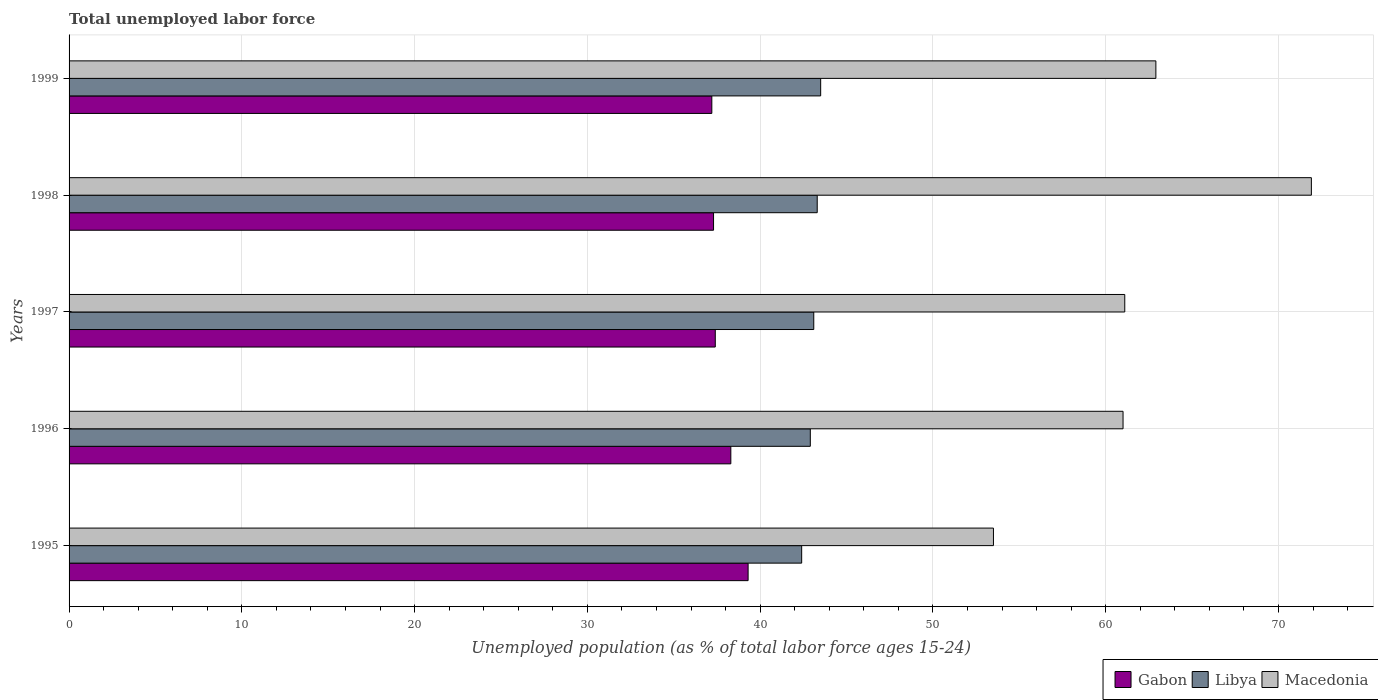How many bars are there on the 4th tick from the top?
Your answer should be compact. 3. How many bars are there on the 1st tick from the bottom?
Ensure brevity in your answer.  3. What is the label of the 3rd group of bars from the top?
Your answer should be very brief. 1997. In how many cases, is the number of bars for a given year not equal to the number of legend labels?
Your answer should be compact. 0. What is the percentage of unemployed population in in Gabon in 1999?
Make the answer very short. 37.2. Across all years, what is the maximum percentage of unemployed population in in Gabon?
Your answer should be very brief. 39.3. Across all years, what is the minimum percentage of unemployed population in in Libya?
Offer a terse response. 42.4. What is the total percentage of unemployed population in in Macedonia in the graph?
Make the answer very short. 310.4. What is the difference between the percentage of unemployed population in in Gabon in 1995 and that in 1997?
Provide a short and direct response. 1.9. What is the difference between the percentage of unemployed population in in Libya in 1997 and the percentage of unemployed population in in Gabon in 1998?
Give a very brief answer. 5.8. What is the average percentage of unemployed population in in Libya per year?
Provide a succinct answer. 43.04. In the year 1997, what is the difference between the percentage of unemployed population in in Gabon and percentage of unemployed population in in Libya?
Make the answer very short. -5.7. In how many years, is the percentage of unemployed population in in Libya greater than 68 %?
Ensure brevity in your answer.  0. What is the ratio of the percentage of unemployed population in in Gabon in 1995 to that in 1996?
Ensure brevity in your answer.  1.03. Is the percentage of unemployed population in in Gabon in 1995 less than that in 1996?
Ensure brevity in your answer.  No. What is the difference between the highest and the second highest percentage of unemployed population in in Libya?
Make the answer very short. 0.2. What is the difference between the highest and the lowest percentage of unemployed population in in Libya?
Your answer should be compact. 1.1. In how many years, is the percentage of unemployed population in in Gabon greater than the average percentage of unemployed population in in Gabon taken over all years?
Give a very brief answer. 2. Is the sum of the percentage of unemployed population in in Libya in 1998 and 1999 greater than the maximum percentage of unemployed population in in Gabon across all years?
Your answer should be very brief. Yes. What does the 1st bar from the top in 1998 represents?
Provide a succinct answer. Macedonia. What does the 2nd bar from the bottom in 1998 represents?
Keep it short and to the point. Libya. How many bars are there?
Make the answer very short. 15. How many years are there in the graph?
Provide a short and direct response. 5. What is the difference between two consecutive major ticks on the X-axis?
Offer a very short reply. 10. Are the values on the major ticks of X-axis written in scientific E-notation?
Keep it short and to the point. No. Does the graph contain any zero values?
Provide a succinct answer. No. Does the graph contain grids?
Provide a short and direct response. Yes. Where does the legend appear in the graph?
Provide a short and direct response. Bottom right. How many legend labels are there?
Your answer should be compact. 3. What is the title of the graph?
Keep it short and to the point. Total unemployed labor force. Does "South Africa" appear as one of the legend labels in the graph?
Your response must be concise. No. What is the label or title of the X-axis?
Provide a short and direct response. Unemployed population (as % of total labor force ages 15-24). What is the label or title of the Y-axis?
Your response must be concise. Years. What is the Unemployed population (as % of total labor force ages 15-24) of Gabon in 1995?
Provide a succinct answer. 39.3. What is the Unemployed population (as % of total labor force ages 15-24) in Libya in 1995?
Your answer should be very brief. 42.4. What is the Unemployed population (as % of total labor force ages 15-24) of Macedonia in 1995?
Keep it short and to the point. 53.5. What is the Unemployed population (as % of total labor force ages 15-24) of Gabon in 1996?
Ensure brevity in your answer.  38.3. What is the Unemployed population (as % of total labor force ages 15-24) in Libya in 1996?
Ensure brevity in your answer.  42.9. What is the Unemployed population (as % of total labor force ages 15-24) of Macedonia in 1996?
Keep it short and to the point. 61. What is the Unemployed population (as % of total labor force ages 15-24) of Gabon in 1997?
Your response must be concise. 37.4. What is the Unemployed population (as % of total labor force ages 15-24) of Libya in 1997?
Offer a terse response. 43.1. What is the Unemployed population (as % of total labor force ages 15-24) of Macedonia in 1997?
Your response must be concise. 61.1. What is the Unemployed population (as % of total labor force ages 15-24) in Gabon in 1998?
Offer a terse response. 37.3. What is the Unemployed population (as % of total labor force ages 15-24) in Libya in 1998?
Keep it short and to the point. 43.3. What is the Unemployed population (as % of total labor force ages 15-24) of Macedonia in 1998?
Provide a succinct answer. 71.9. What is the Unemployed population (as % of total labor force ages 15-24) of Gabon in 1999?
Make the answer very short. 37.2. What is the Unemployed population (as % of total labor force ages 15-24) of Libya in 1999?
Ensure brevity in your answer.  43.5. What is the Unemployed population (as % of total labor force ages 15-24) of Macedonia in 1999?
Offer a very short reply. 62.9. Across all years, what is the maximum Unemployed population (as % of total labor force ages 15-24) of Gabon?
Give a very brief answer. 39.3. Across all years, what is the maximum Unemployed population (as % of total labor force ages 15-24) in Libya?
Provide a short and direct response. 43.5. Across all years, what is the maximum Unemployed population (as % of total labor force ages 15-24) of Macedonia?
Ensure brevity in your answer.  71.9. Across all years, what is the minimum Unemployed population (as % of total labor force ages 15-24) of Gabon?
Your answer should be compact. 37.2. Across all years, what is the minimum Unemployed population (as % of total labor force ages 15-24) in Libya?
Your response must be concise. 42.4. Across all years, what is the minimum Unemployed population (as % of total labor force ages 15-24) of Macedonia?
Your answer should be very brief. 53.5. What is the total Unemployed population (as % of total labor force ages 15-24) in Gabon in the graph?
Offer a very short reply. 189.5. What is the total Unemployed population (as % of total labor force ages 15-24) of Libya in the graph?
Provide a short and direct response. 215.2. What is the total Unemployed population (as % of total labor force ages 15-24) of Macedonia in the graph?
Provide a succinct answer. 310.4. What is the difference between the Unemployed population (as % of total labor force ages 15-24) in Libya in 1995 and that in 1996?
Your answer should be very brief. -0.5. What is the difference between the Unemployed population (as % of total labor force ages 15-24) in Macedonia in 1995 and that in 1996?
Offer a very short reply. -7.5. What is the difference between the Unemployed population (as % of total labor force ages 15-24) in Gabon in 1995 and that in 1997?
Your response must be concise. 1.9. What is the difference between the Unemployed population (as % of total labor force ages 15-24) of Libya in 1995 and that in 1997?
Offer a very short reply. -0.7. What is the difference between the Unemployed population (as % of total labor force ages 15-24) of Libya in 1995 and that in 1998?
Offer a very short reply. -0.9. What is the difference between the Unemployed population (as % of total labor force ages 15-24) of Macedonia in 1995 and that in 1998?
Provide a short and direct response. -18.4. What is the difference between the Unemployed population (as % of total labor force ages 15-24) in Macedonia in 1995 and that in 1999?
Offer a terse response. -9.4. What is the difference between the Unemployed population (as % of total labor force ages 15-24) in Gabon in 1996 and that in 1997?
Your answer should be compact. 0.9. What is the difference between the Unemployed population (as % of total labor force ages 15-24) of Libya in 1996 and that in 1997?
Give a very brief answer. -0.2. What is the difference between the Unemployed population (as % of total labor force ages 15-24) in Gabon in 1996 and that in 1998?
Give a very brief answer. 1. What is the difference between the Unemployed population (as % of total labor force ages 15-24) of Libya in 1996 and that in 1998?
Give a very brief answer. -0.4. What is the difference between the Unemployed population (as % of total labor force ages 15-24) in Macedonia in 1997 and that in 1999?
Ensure brevity in your answer.  -1.8. What is the difference between the Unemployed population (as % of total labor force ages 15-24) in Gabon in 1998 and that in 1999?
Your answer should be compact. 0.1. What is the difference between the Unemployed population (as % of total labor force ages 15-24) in Libya in 1998 and that in 1999?
Your answer should be very brief. -0.2. What is the difference between the Unemployed population (as % of total labor force ages 15-24) of Gabon in 1995 and the Unemployed population (as % of total labor force ages 15-24) of Macedonia in 1996?
Make the answer very short. -21.7. What is the difference between the Unemployed population (as % of total labor force ages 15-24) in Libya in 1995 and the Unemployed population (as % of total labor force ages 15-24) in Macedonia in 1996?
Ensure brevity in your answer.  -18.6. What is the difference between the Unemployed population (as % of total labor force ages 15-24) in Gabon in 1995 and the Unemployed population (as % of total labor force ages 15-24) in Macedonia in 1997?
Your response must be concise. -21.8. What is the difference between the Unemployed population (as % of total labor force ages 15-24) of Libya in 1995 and the Unemployed population (as % of total labor force ages 15-24) of Macedonia in 1997?
Provide a succinct answer. -18.7. What is the difference between the Unemployed population (as % of total labor force ages 15-24) in Gabon in 1995 and the Unemployed population (as % of total labor force ages 15-24) in Macedonia in 1998?
Give a very brief answer. -32.6. What is the difference between the Unemployed population (as % of total labor force ages 15-24) of Libya in 1995 and the Unemployed population (as % of total labor force ages 15-24) of Macedonia in 1998?
Your answer should be very brief. -29.5. What is the difference between the Unemployed population (as % of total labor force ages 15-24) in Gabon in 1995 and the Unemployed population (as % of total labor force ages 15-24) in Libya in 1999?
Your answer should be compact. -4.2. What is the difference between the Unemployed population (as % of total labor force ages 15-24) in Gabon in 1995 and the Unemployed population (as % of total labor force ages 15-24) in Macedonia in 1999?
Offer a very short reply. -23.6. What is the difference between the Unemployed population (as % of total labor force ages 15-24) in Libya in 1995 and the Unemployed population (as % of total labor force ages 15-24) in Macedonia in 1999?
Give a very brief answer. -20.5. What is the difference between the Unemployed population (as % of total labor force ages 15-24) of Gabon in 1996 and the Unemployed population (as % of total labor force ages 15-24) of Macedonia in 1997?
Provide a succinct answer. -22.8. What is the difference between the Unemployed population (as % of total labor force ages 15-24) in Libya in 1996 and the Unemployed population (as % of total labor force ages 15-24) in Macedonia in 1997?
Ensure brevity in your answer.  -18.2. What is the difference between the Unemployed population (as % of total labor force ages 15-24) of Gabon in 1996 and the Unemployed population (as % of total labor force ages 15-24) of Macedonia in 1998?
Give a very brief answer. -33.6. What is the difference between the Unemployed population (as % of total labor force ages 15-24) of Gabon in 1996 and the Unemployed population (as % of total labor force ages 15-24) of Libya in 1999?
Your answer should be very brief. -5.2. What is the difference between the Unemployed population (as % of total labor force ages 15-24) of Gabon in 1996 and the Unemployed population (as % of total labor force ages 15-24) of Macedonia in 1999?
Offer a terse response. -24.6. What is the difference between the Unemployed population (as % of total labor force ages 15-24) in Libya in 1996 and the Unemployed population (as % of total labor force ages 15-24) in Macedonia in 1999?
Ensure brevity in your answer.  -20. What is the difference between the Unemployed population (as % of total labor force ages 15-24) of Gabon in 1997 and the Unemployed population (as % of total labor force ages 15-24) of Macedonia in 1998?
Ensure brevity in your answer.  -34.5. What is the difference between the Unemployed population (as % of total labor force ages 15-24) of Libya in 1997 and the Unemployed population (as % of total labor force ages 15-24) of Macedonia in 1998?
Provide a short and direct response. -28.8. What is the difference between the Unemployed population (as % of total labor force ages 15-24) of Gabon in 1997 and the Unemployed population (as % of total labor force ages 15-24) of Macedonia in 1999?
Your response must be concise. -25.5. What is the difference between the Unemployed population (as % of total labor force ages 15-24) of Libya in 1997 and the Unemployed population (as % of total labor force ages 15-24) of Macedonia in 1999?
Make the answer very short. -19.8. What is the difference between the Unemployed population (as % of total labor force ages 15-24) in Gabon in 1998 and the Unemployed population (as % of total labor force ages 15-24) in Libya in 1999?
Provide a succinct answer. -6.2. What is the difference between the Unemployed population (as % of total labor force ages 15-24) of Gabon in 1998 and the Unemployed population (as % of total labor force ages 15-24) of Macedonia in 1999?
Your answer should be very brief. -25.6. What is the difference between the Unemployed population (as % of total labor force ages 15-24) in Libya in 1998 and the Unemployed population (as % of total labor force ages 15-24) in Macedonia in 1999?
Ensure brevity in your answer.  -19.6. What is the average Unemployed population (as % of total labor force ages 15-24) in Gabon per year?
Make the answer very short. 37.9. What is the average Unemployed population (as % of total labor force ages 15-24) in Libya per year?
Offer a very short reply. 43.04. What is the average Unemployed population (as % of total labor force ages 15-24) in Macedonia per year?
Keep it short and to the point. 62.08. In the year 1995, what is the difference between the Unemployed population (as % of total labor force ages 15-24) in Gabon and Unemployed population (as % of total labor force ages 15-24) in Libya?
Provide a succinct answer. -3.1. In the year 1996, what is the difference between the Unemployed population (as % of total labor force ages 15-24) of Gabon and Unemployed population (as % of total labor force ages 15-24) of Libya?
Offer a very short reply. -4.6. In the year 1996, what is the difference between the Unemployed population (as % of total labor force ages 15-24) in Gabon and Unemployed population (as % of total labor force ages 15-24) in Macedonia?
Your answer should be compact. -22.7. In the year 1996, what is the difference between the Unemployed population (as % of total labor force ages 15-24) in Libya and Unemployed population (as % of total labor force ages 15-24) in Macedonia?
Your answer should be very brief. -18.1. In the year 1997, what is the difference between the Unemployed population (as % of total labor force ages 15-24) in Gabon and Unemployed population (as % of total labor force ages 15-24) in Macedonia?
Provide a short and direct response. -23.7. In the year 1998, what is the difference between the Unemployed population (as % of total labor force ages 15-24) in Gabon and Unemployed population (as % of total labor force ages 15-24) in Libya?
Your response must be concise. -6. In the year 1998, what is the difference between the Unemployed population (as % of total labor force ages 15-24) of Gabon and Unemployed population (as % of total labor force ages 15-24) of Macedonia?
Offer a very short reply. -34.6. In the year 1998, what is the difference between the Unemployed population (as % of total labor force ages 15-24) of Libya and Unemployed population (as % of total labor force ages 15-24) of Macedonia?
Give a very brief answer. -28.6. In the year 1999, what is the difference between the Unemployed population (as % of total labor force ages 15-24) of Gabon and Unemployed population (as % of total labor force ages 15-24) of Macedonia?
Provide a succinct answer. -25.7. In the year 1999, what is the difference between the Unemployed population (as % of total labor force ages 15-24) of Libya and Unemployed population (as % of total labor force ages 15-24) of Macedonia?
Offer a very short reply. -19.4. What is the ratio of the Unemployed population (as % of total labor force ages 15-24) in Gabon in 1995 to that in 1996?
Ensure brevity in your answer.  1.03. What is the ratio of the Unemployed population (as % of total labor force ages 15-24) in Libya in 1995 to that in 1996?
Keep it short and to the point. 0.99. What is the ratio of the Unemployed population (as % of total labor force ages 15-24) in Macedonia in 1995 to that in 1996?
Your answer should be compact. 0.88. What is the ratio of the Unemployed population (as % of total labor force ages 15-24) of Gabon in 1995 to that in 1997?
Offer a very short reply. 1.05. What is the ratio of the Unemployed population (as % of total labor force ages 15-24) in Libya in 1995 to that in 1997?
Provide a succinct answer. 0.98. What is the ratio of the Unemployed population (as % of total labor force ages 15-24) in Macedonia in 1995 to that in 1997?
Your answer should be compact. 0.88. What is the ratio of the Unemployed population (as % of total labor force ages 15-24) in Gabon in 1995 to that in 1998?
Provide a short and direct response. 1.05. What is the ratio of the Unemployed population (as % of total labor force ages 15-24) of Libya in 1995 to that in 1998?
Your response must be concise. 0.98. What is the ratio of the Unemployed population (as % of total labor force ages 15-24) in Macedonia in 1995 to that in 1998?
Provide a short and direct response. 0.74. What is the ratio of the Unemployed population (as % of total labor force ages 15-24) of Gabon in 1995 to that in 1999?
Offer a terse response. 1.06. What is the ratio of the Unemployed population (as % of total labor force ages 15-24) of Libya in 1995 to that in 1999?
Offer a very short reply. 0.97. What is the ratio of the Unemployed population (as % of total labor force ages 15-24) of Macedonia in 1995 to that in 1999?
Offer a very short reply. 0.85. What is the ratio of the Unemployed population (as % of total labor force ages 15-24) of Gabon in 1996 to that in 1997?
Give a very brief answer. 1.02. What is the ratio of the Unemployed population (as % of total labor force ages 15-24) in Gabon in 1996 to that in 1998?
Provide a short and direct response. 1.03. What is the ratio of the Unemployed population (as % of total labor force ages 15-24) of Macedonia in 1996 to that in 1998?
Make the answer very short. 0.85. What is the ratio of the Unemployed population (as % of total labor force ages 15-24) of Gabon in 1996 to that in 1999?
Offer a terse response. 1.03. What is the ratio of the Unemployed population (as % of total labor force ages 15-24) of Libya in 1996 to that in 1999?
Offer a terse response. 0.99. What is the ratio of the Unemployed population (as % of total labor force ages 15-24) in Macedonia in 1996 to that in 1999?
Your answer should be very brief. 0.97. What is the ratio of the Unemployed population (as % of total labor force ages 15-24) of Macedonia in 1997 to that in 1998?
Provide a succinct answer. 0.85. What is the ratio of the Unemployed population (as % of total labor force ages 15-24) of Gabon in 1997 to that in 1999?
Provide a short and direct response. 1.01. What is the ratio of the Unemployed population (as % of total labor force ages 15-24) in Macedonia in 1997 to that in 1999?
Your answer should be compact. 0.97. What is the ratio of the Unemployed population (as % of total labor force ages 15-24) of Libya in 1998 to that in 1999?
Make the answer very short. 1. What is the ratio of the Unemployed population (as % of total labor force ages 15-24) in Macedonia in 1998 to that in 1999?
Make the answer very short. 1.14. What is the difference between the highest and the second highest Unemployed population (as % of total labor force ages 15-24) in Libya?
Your answer should be very brief. 0.2. What is the difference between the highest and the lowest Unemployed population (as % of total labor force ages 15-24) in Gabon?
Keep it short and to the point. 2.1. 